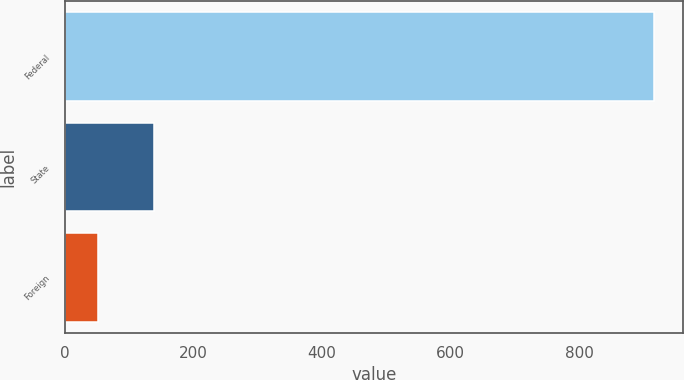Convert chart to OTSL. <chart><loc_0><loc_0><loc_500><loc_500><bar_chart><fcel>Federal<fcel>State<fcel>Foreign<nl><fcel>916<fcel>138.4<fcel>52<nl></chart> 